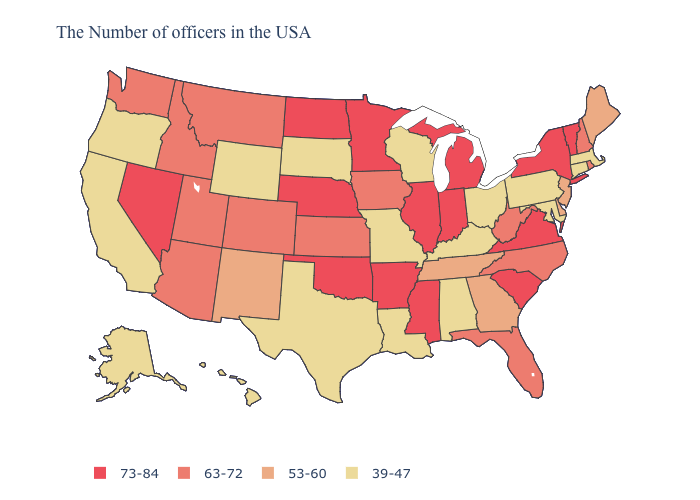Name the states that have a value in the range 63-72?
Quick response, please. Rhode Island, New Hampshire, North Carolina, West Virginia, Florida, Iowa, Kansas, Colorado, Utah, Montana, Arizona, Idaho, Washington. Which states have the lowest value in the USA?
Answer briefly. Massachusetts, Connecticut, Maryland, Pennsylvania, Ohio, Kentucky, Alabama, Wisconsin, Louisiana, Missouri, Texas, South Dakota, Wyoming, California, Oregon, Alaska, Hawaii. Among the states that border Texas , which have the lowest value?
Give a very brief answer. Louisiana. What is the lowest value in states that border Virginia?
Concise answer only. 39-47. What is the lowest value in states that border Wyoming?
Write a very short answer. 39-47. Name the states that have a value in the range 39-47?
Concise answer only. Massachusetts, Connecticut, Maryland, Pennsylvania, Ohio, Kentucky, Alabama, Wisconsin, Louisiana, Missouri, Texas, South Dakota, Wyoming, California, Oregon, Alaska, Hawaii. Name the states that have a value in the range 53-60?
Keep it brief. Maine, New Jersey, Delaware, Georgia, Tennessee, New Mexico. What is the value of Tennessee?
Answer briefly. 53-60. Name the states that have a value in the range 63-72?
Quick response, please. Rhode Island, New Hampshire, North Carolina, West Virginia, Florida, Iowa, Kansas, Colorado, Utah, Montana, Arizona, Idaho, Washington. What is the value of Colorado?
Answer briefly. 63-72. Does Hawaii have a lower value than Colorado?
Concise answer only. Yes. Does Rhode Island have the lowest value in the USA?
Concise answer only. No. Name the states that have a value in the range 63-72?
Write a very short answer. Rhode Island, New Hampshire, North Carolina, West Virginia, Florida, Iowa, Kansas, Colorado, Utah, Montana, Arizona, Idaho, Washington. Name the states that have a value in the range 39-47?
Give a very brief answer. Massachusetts, Connecticut, Maryland, Pennsylvania, Ohio, Kentucky, Alabama, Wisconsin, Louisiana, Missouri, Texas, South Dakota, Wyoming, California, Oregon, Alaska, Hawaii. What is the value of Utah?
Be succinct. 63-72. 